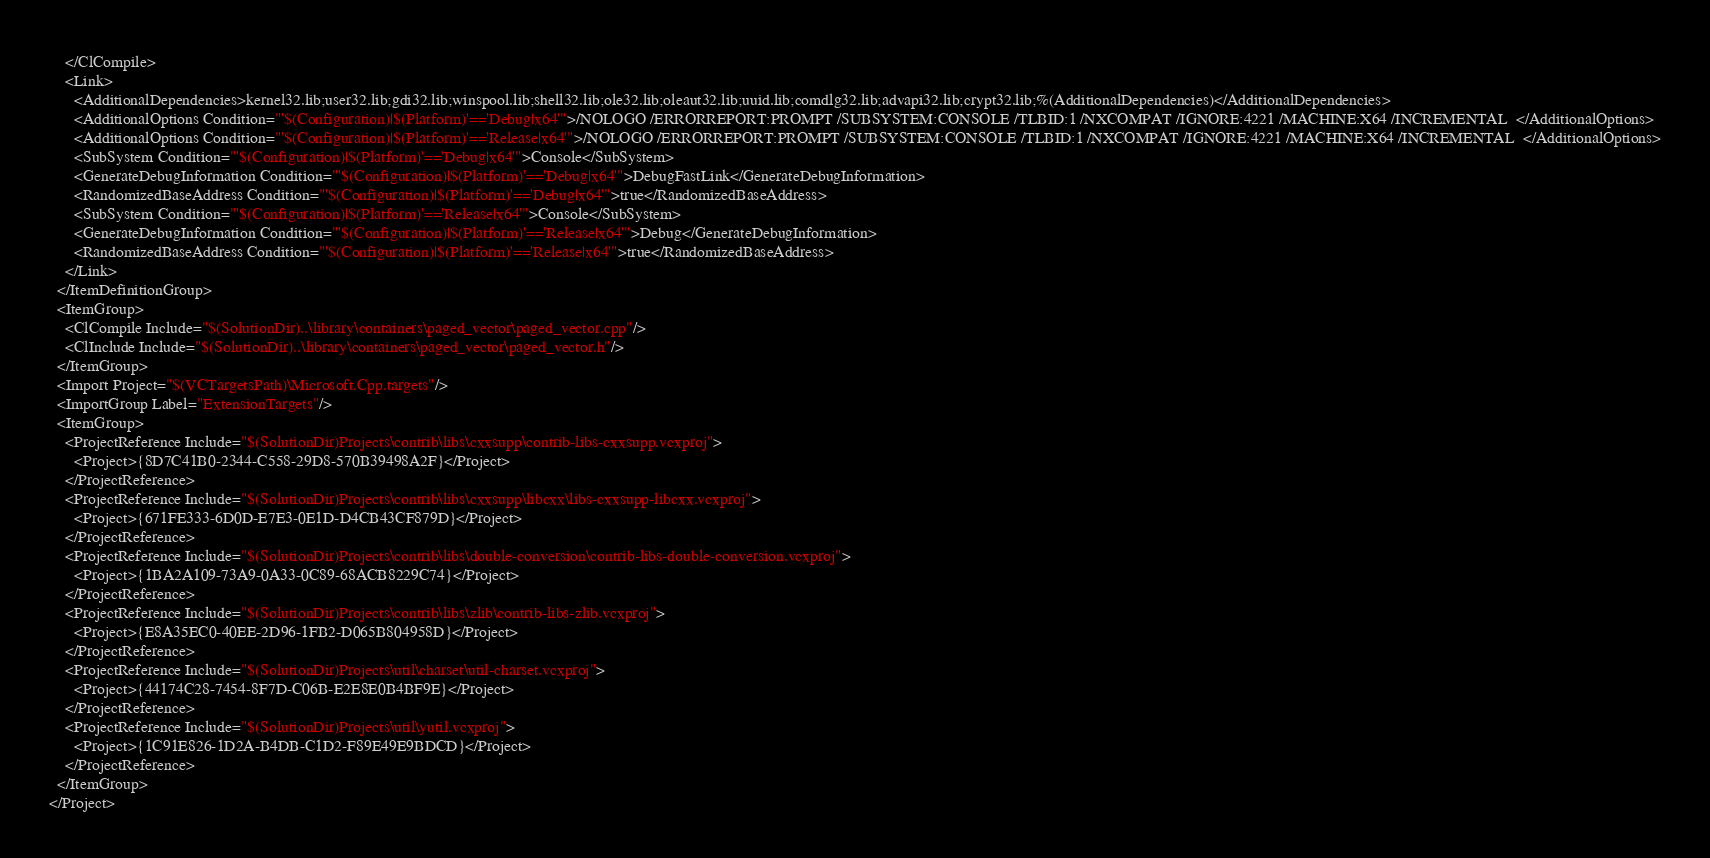Convert code to text. <code><loc_0><loc_0><loc_500><loc_500><_XML_>    </ClCompile>
    <Link>
      <AdditionalDependencies>kernel32.lib;user32.lib;gdi32.lib;winspool.lib;shell32.lib;ole32.lib;oleaut32.lib;uuid.lib;comdlg32.lib;advapi32.lib;crypt32.lib;%(AdditionalDependencies)</AdditionalDependencies>
      <AdditionalOptions Condition="'$(Configuration)|$(Platform)'=='Debug|x64'">/NOLOGO /ERRORREPORT:PROMPT /SUBSYSTEM:CONSOLE /TLBID:1 /NXCOMPAT /IGNORE:4221 /MACHINE:X64 /INCREMENTAL  </AdditionalOptions>
      <AdditionalOptions Condition="'$(Configuration)|$(Platform)'=='Release|x64'">/NOLOGO /ERRORREPORT:PROMPT /SUBSYSTEM:CONSOLE /TLBID:1 /NXCOMPAT /IGNORE:4221 /MACHINE:X64 /INCREMENTAL  </AdditionalOptions>
      <SubSystem Condition="'$(Configuration)|$(Platform)'=='Debug|x64'">Console</SubSystem>
      <GenerateDebugInformation Condition="'$(Configuration)|$(Platform)'=='Debug|x64'">DebugFastLink</GenerateDebugInformation>
      <RandomizedBaseAddress Condition="'$(Configuration)|$(Platform)'=='Debug|x64'">true</RandomizedBaseAddress>
      <SubSystem Condition="'$(Configuration)|$(Platform)'=='Release|x64'">Console</SubSystem>
      <GenerateDebugInformation Condition="'$(Configuration)|$(Platform)'=='Release|x64'">Debug</GenerateDebugInformation>
      <RandomizedBaseAddress Condition="'$(Configuration)|$(Platform)'=='Release|x64'">true</RandomizedBaseAddress>
    </Link>
  </ItemDefinitionGroup>
  <ItemGroup>
    <ClCompile Include="$(SolutionDir)..\library\containers\paged_vector\paged_vector.cpp"/>
    <ClInclude Include="$(SolutionDir)..\library\containers\paged_vector\paged_vector.h"/>
  </ItemGroup>
  <Import Project="$(VCTargetsPath)\Microsoft.Cpp.targets"/>
  <ImportGroup Label="ExtensionTargets"/>
  <ItemGroup>
    <ProjectReference Include="$(SolutionDir)Projects\contrib\libs\cxxsupp\contrib-libs-cxxsupp.vcxproj">
      <Project>{8D7C41B0-2344-C558-29D8-570B39498A2F}</Project>
    </ProjectReference>
    <ProjectReference Include="$(SolutionDir)Projects\contrib\libs\cxxsupp\libcxx\libs-cxxsupp-libcxx.vcxproj">
      <Project>{671FE333-6D0D-E7E3-0E1D-D4CB43CF879D}</Project>
    </ProjectReference>
    <ProjectReference Include="$(SolutionDir)Projects\contrib\libs\double-conversion\contrib-libs-double-conversion.vcxproj">
      <Project>{1BA2A109-73A9-0A33-0C89-68ACB8229C74}</Project>
    </ProjectReference>
    <ProjectReference Include="$(SolutionDir)Projects\contrib\libs\zlib\contrib-libs-zlib.vcxproj">
      <Project>{E8A35EC0-40EE-2D96-1FB2-D065B804958D}</Project>
    </ProjectReference>
    <ProjectReference Include="$(SolutionDir)Projects\util\charset\util-charset.vcxproj">
      <Project>{44174C28-7454-8F7D-C06B-E2E8E0B4BF9E}</Project>
    </ProjectReference>
    <ProjectReference Include="$(SolutionDir)Projects\util\yutil.vcxproj">
      <Project>{1C91E826-1D2A-B4DB-C1D2-F89E49E9BDCD}</Project>
    </ProjectReference>
  </ItemGroup>
</Project>
</code> 